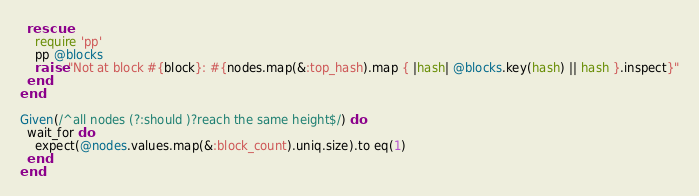Convert code to text. <code><loc_0><loc_0><loc_500><loc_500><_Ruby_>  rescue
    require 'pp'
    pp @blocks
    raise "Not at block #{block}: #{nodes.map(&:top_hash).map { |hash| @blocks.key(hash) || hash }.inspect}"
  end
end

Given(/^all nodes (?:should )?reach the same height$/) do
  wait_for do
    expect(@nodes.values.map(&:block_count).uniq.size).to eq(1)
  end
end
</code> 